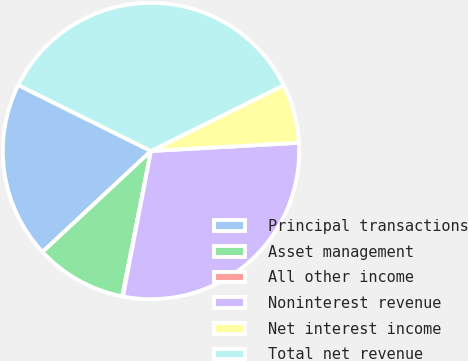<chart> <loc_0><loc_0><loc_500><loc_500><pie_chart><fcel>Principal transactions<fcel>Asset management<fcel>All other income<fcel>Noninterest revenue<fcel>Net interest income<fcel>Total net revenue<nl><fcel>19.27%<fcel>9.96%<fcel>0.08%<fcel>28.92%<fcel>6.43%<fcel>35.35%<nl></chart> 